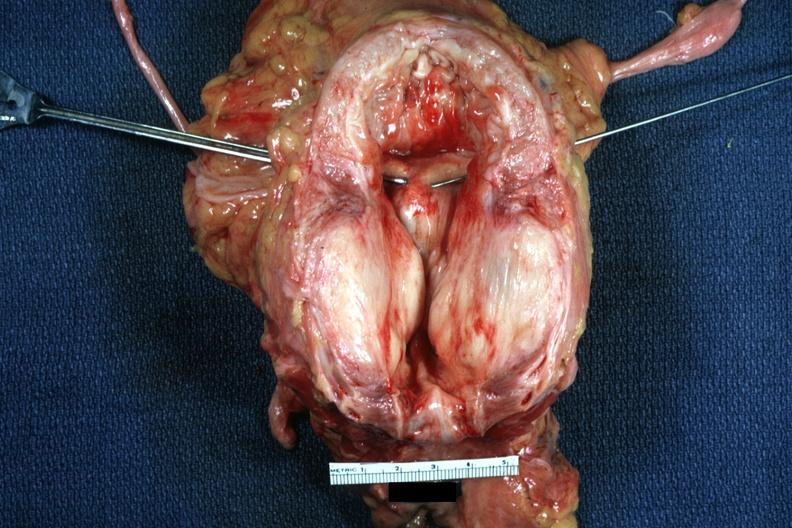s prostate present?
Answer the question using a single word or phrase. Yes 